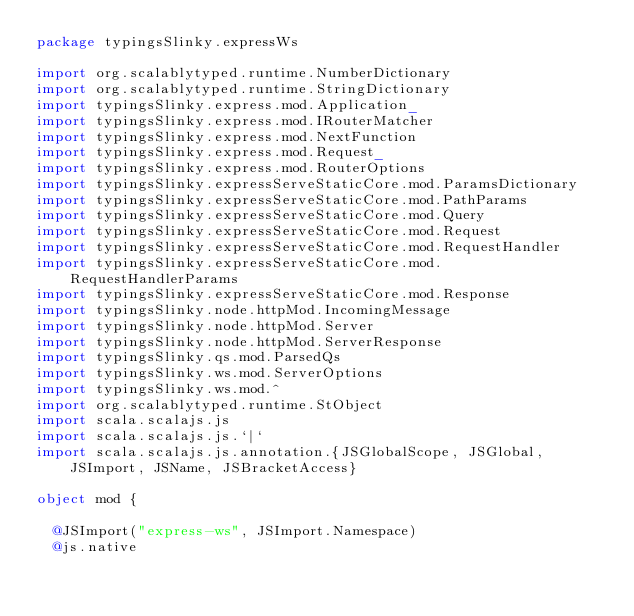Convert code to text. <code><loc_0><loc_0><loc_500><loc_500><_Scala_>package typingsSlinky.expressWs

import org.scalablytyped.runtime.NumberDictionary
import org.scalablytyped.runtime.StringDictionary
import typingsSlinky.express.mod.Application_
import typingsSlinky.express.mod.IRouterMatcher
import typingsSlinky.express.mod.NextFunction
import typingsSlinky.express.mod.Request_
import typingsSlinky.express.mod.RouterOptions
import typingsSlinky.expressServeStaticCore.mod.ParamsDictionary
import typingsSlinky.expressServeStaticCore.mod.PathParams
import typingsSlinky.expressServeStaticCore.mod.Query
import typingsSlinky.expressServeStaticCore.mod.Request
import typingsSlinky.expressServeStaticCore.mod.RequestHandler
import typingsSlinky.expressServeStaticCore.mod.RequestHandlerParams
import typingsSlinky.expressServeStaticCore.mod.Response
import typingsSlinky.node.httpMod.IncomingMessage
import typingsSlinky.node.httpMod.Server
import typingsSlinky.node.httpMod.ServerResponse
import typingsSlinky.qs.mod.ParsedQs
import typingsSlinky.ws.mod.ServerOptions
import typingsSlinky.ws.mod.^
import org.scalablytyped.runtime.StObject
import scala.scalajs.js
import scala.scalajs.js.`|`
import scala.scalajs.js.annotation.{JSGlobalScope, JSGlobal, JSImport, JSName, JSBracketAccess}

object mod {
  
  @JSImport("express-ws", JSImport.Namespace)
  @js.native</code> 